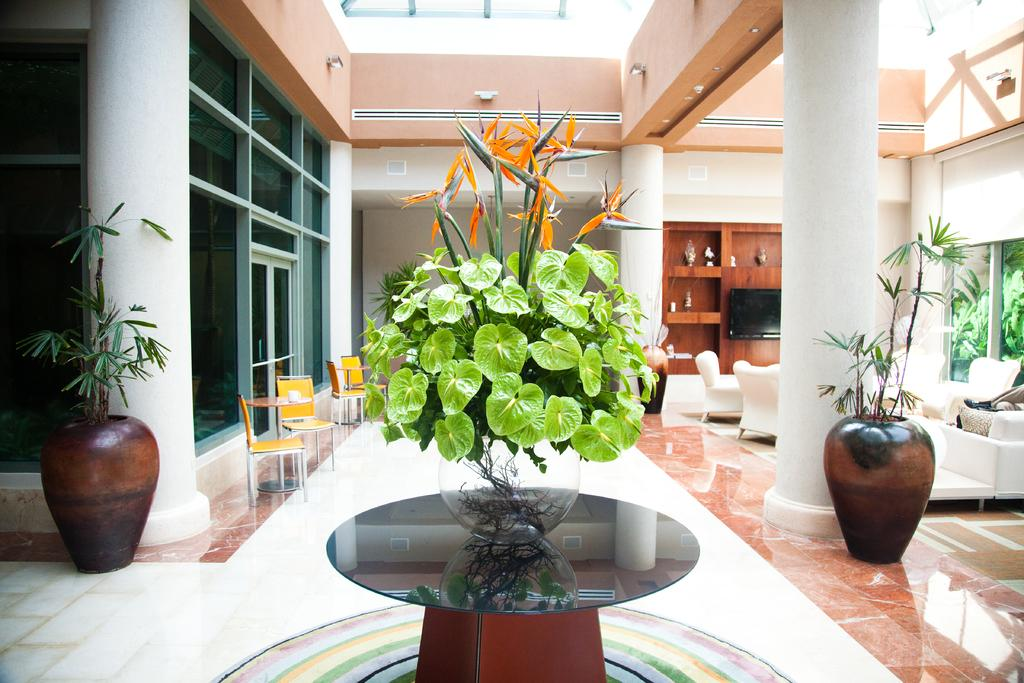What is on the glass table in the image? There is a flower vase on the glass table in the image. What type of seating is present in the image? There is a sofa and yellow chairs in the image. What electronic device can be seen in the image? There is a television in the image. What architectural features are present in the image? There is a window and a door in the image. How many fangs can be seen on the cats in the image? There are no cats present in the image, so there are no fangs to count. What type of washing machine is visible in the image? There is no washing machine present in the image. 